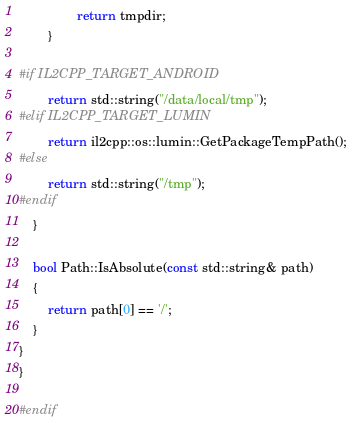Convert code to text. <code><loc_0><loc_0><loc_500><loc_500><_C++_>                return tmpdir;
        }

#if IL2CPP_TARGET_ANDROID
        return std::string("/data/local/tmp");
#elif IL2CPP_TARGET_LUMIN
        return il2cpp::os::lumin::GetPackageTempPath();
#else
        return std::string("/tmp");
#endif
    }

    bool Path::IsAbsolute(const std::string& path)
    {
        return path[0] == '/';
    }
}
}

#endif
</code> 